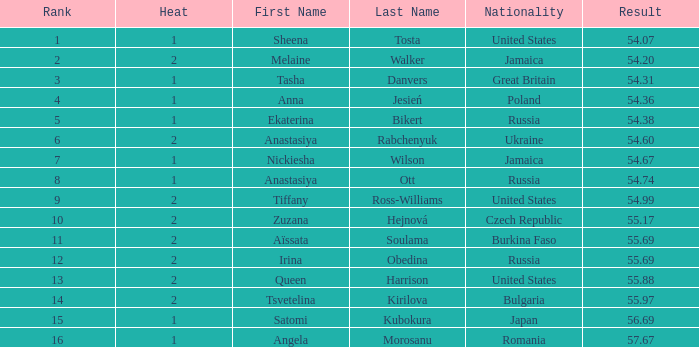Who has a Result of 54.67? Nickiesha Wilson. 